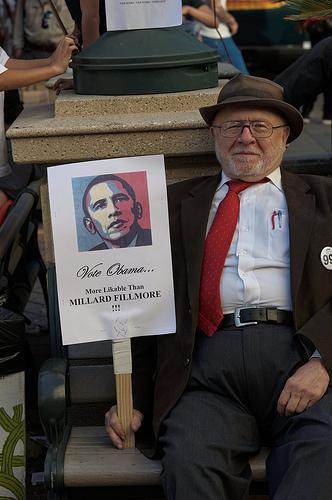How many signs are in the photo?
Give a very brief answer. 1. 